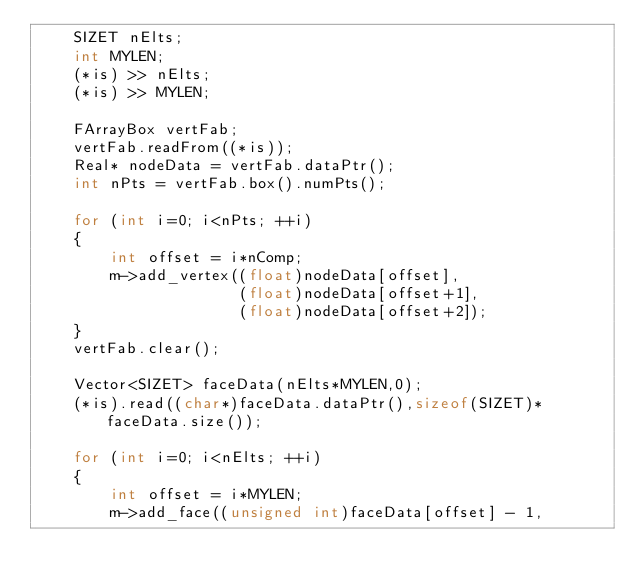Convert code to text. <code><loc_0><loc_0><loc_500><loc_500><_C++_>    SIZET nElts;
    int MYLEN;
    (*is) >> nElts;
    (*is) >> MYLEN;

    FArrayBox vertFab;
    vertFab.readFrom((*is));
    Real* nodeData = vertFab.dataPtr();
    int nPts = vertFab.box().numPts();

    for (int i=0; i<nPts; ++i)
    {
        int offset = i*nComp;
        m->add_vertex((float)nodeData[offset],
                      (float)nodeData[offset+1],
                      (float)nodeData[offset+2]);
    }
    vertFab.clear();

    Vector<SIZET> faceData(nElts*MYLEN,0);
    (*is).read((char*)faceData.dataPtr(),sizeof(SIZET)*faceData.size());

    for (int i=0; i<nElts; ++i)
    {
        int offset = i*MYLEN;
        m->add_face((unsigned int)faceData[offset] - 1,</code> 